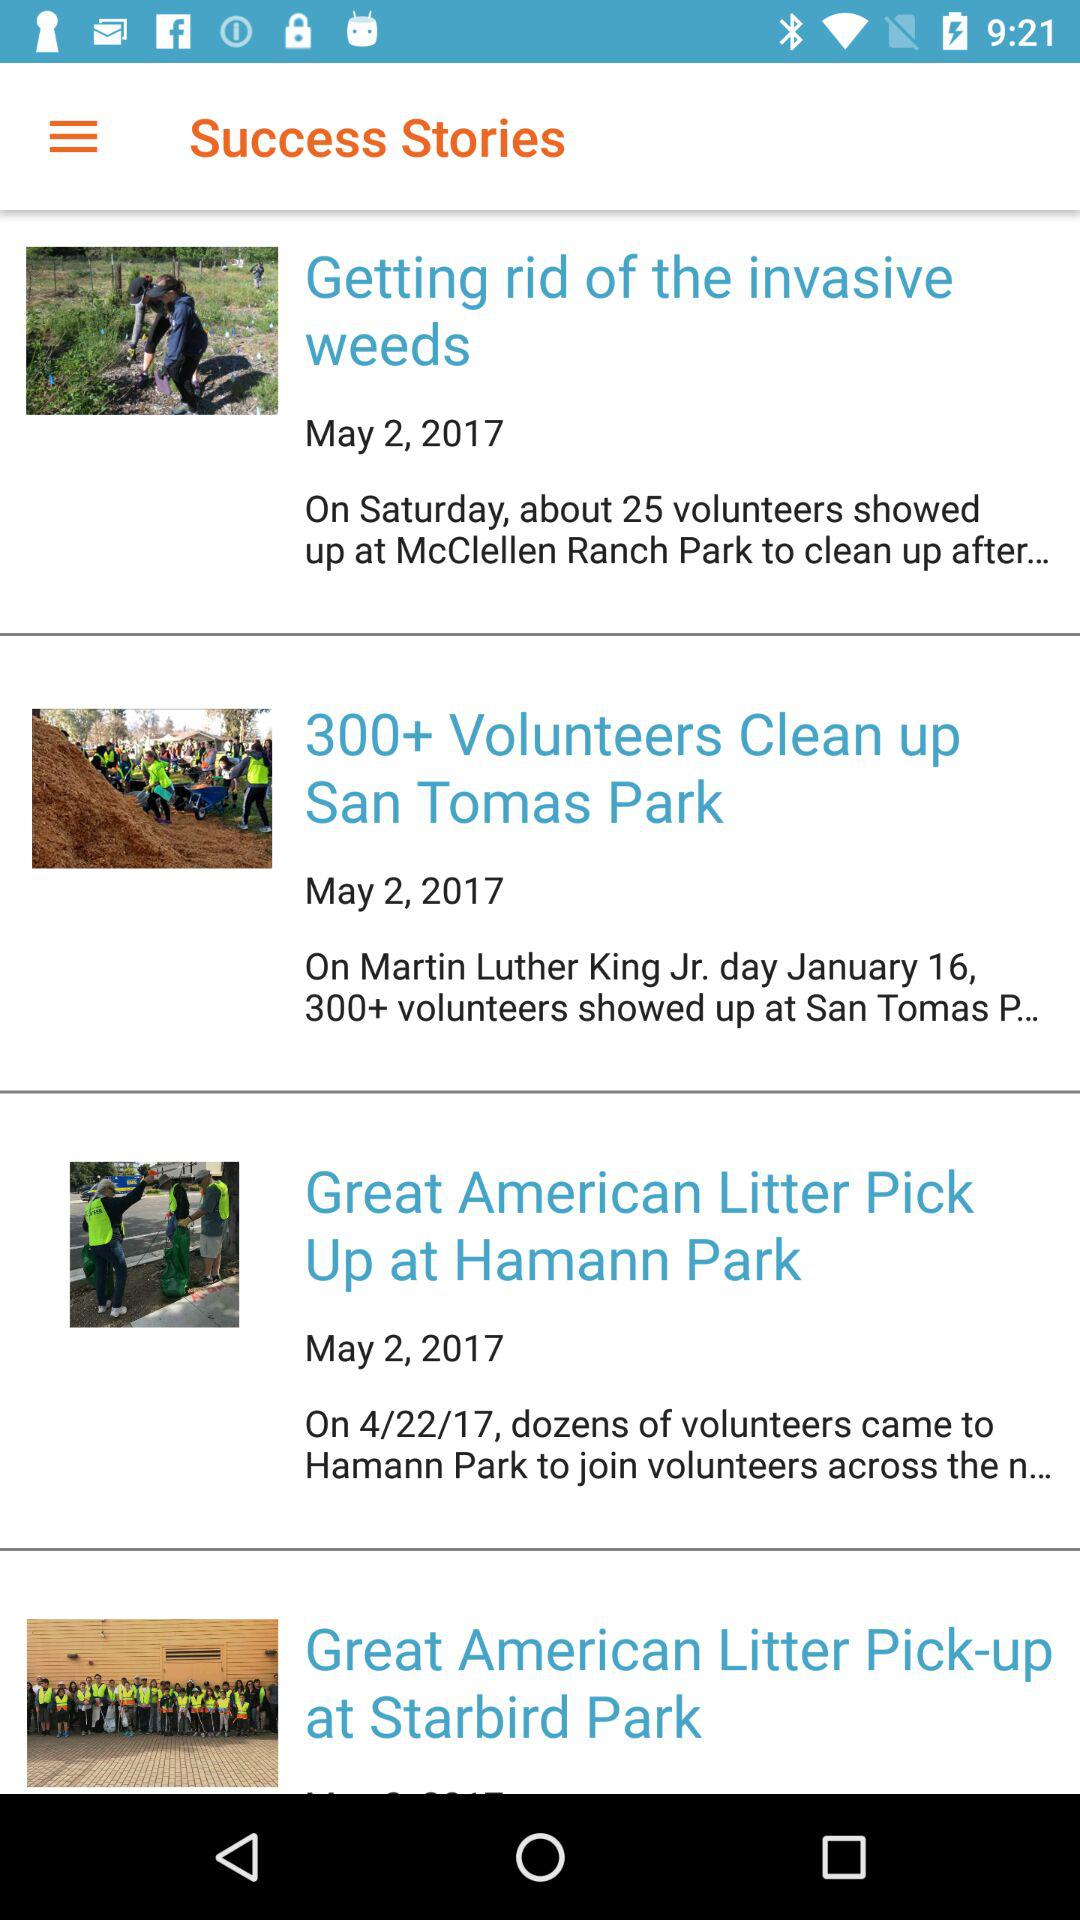What is the time for getting rid of the invasive weeds?
When the provided information is insufficient, respond with <no answer>. <no answer> 